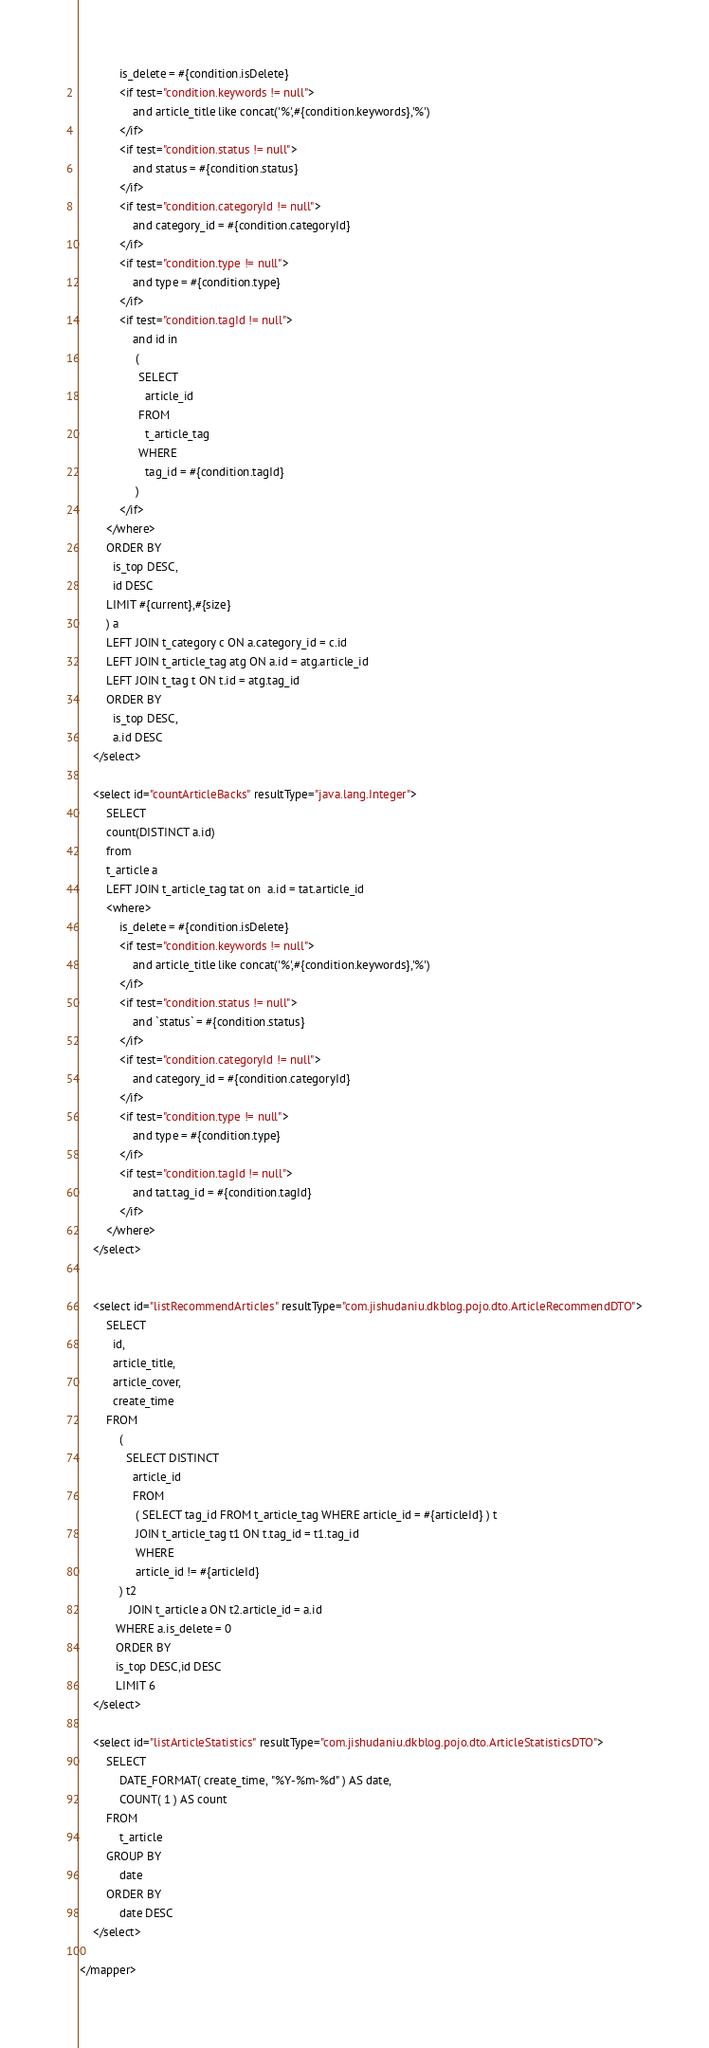Convert code to text. <code><loc_0><loc_0><loc_500><loc_500><_XML_>            is_delete = #{condition.isDelete}
            <if test="condition.keywords != null">
                and article_title like concat('%',#{condition.keywords},'%')
            </if>
            <if test="condition.status != null">
                and status = #{condition.status}
            </if>
            <if test="condition.categoryId != null">
                and category_id = #{condition.categoryId}
            </if>
            <if test="condition.type != null">
                and type = #{condition.type}
            </if>
            <if test="condition.tagId != null">
                and id in
                 (
                  SELECT
                    article_id
                  FROM
                    t_article_tag
                  WHERE
                    tag_id = #{condition.tagId}
                 )
            </if>
        </where>
        ORDER BY
          is_top DESC,
          id DESC
        LIMIT #{current},#{size}
        ) a
        LEFT JOIN t_category c ON a.category_id = c.id
        LEFT JOIN t_article_tag atg ON a.id = atg.article_id
        LEFT JOIN t_tag t ON t.id = atg.tag_id
        ORDER BY
          is_top DESC,
          a.id DESC
    </select>

    <select id="countArticleBacks" resultType="java.lang.Integer">
        SELECT
        count(DISTINCT a.id)
        from
        t_article a
        LEFT JOIN t_article_tag tat on  a.id = tat.article_id
        <where>
            is_delete = #{condition.isDelete}
            <if test="condition.keywords != null">
                and article_title like concat('%',#{condition.keywords},'%')
            </if>
            <if test="condition.status != null">
                and `status` = #{condition.status}
            </if>
            <if test="condition.categoryId != null">
                and category_id = #{condition.categoryId}
            </if>
            <if test="condition.type != null">
                and type = #{condition.type}
            </if>
            <if test="condition.tagId != null">
                and tat.tag_id = #{condition.tagId}
            </if>
        </where>
    </select>


    <select id="listRecommendArticles" resultType="com.jishudaniu.dkblog.pojo.dto.ArticleRecommendDTO">
        SELECT
          id,
          article_title,
          article_cover,
          create_time
        FROM
            (
              SELECT DISTINCT
                article_id
                FROM
                 ( SELECT tag_id FROM t_article_tag WHERE article_id = #{articleId} ) t
                 JOIN t_article_tag t1 ON t.tag_id = t1.tag_id
                 WHERE
                 article_id != #{articleId}
            ) t2
               JOIN t_article a ON t2.article_id = a.id
           WHERE a.is_delete = 0
           ORDER BY
           is_top DESC,id DESC
           LIMIT 6
    </select>

    <select id="listArticleStatistics" resultType="com.jishudaniu.dkblog.pojo.dto.ArticleStatisticsDTO">
        SELECT
            DATE_FORMAT( create_time, "%Y-%m-%d" ) AS date,
            COUNT( 1 ) AS count
        FROM
            t_article
        GROUP BY
            date
        ORDER BY
            date DESC
    </select>

</mapper>
</code> 